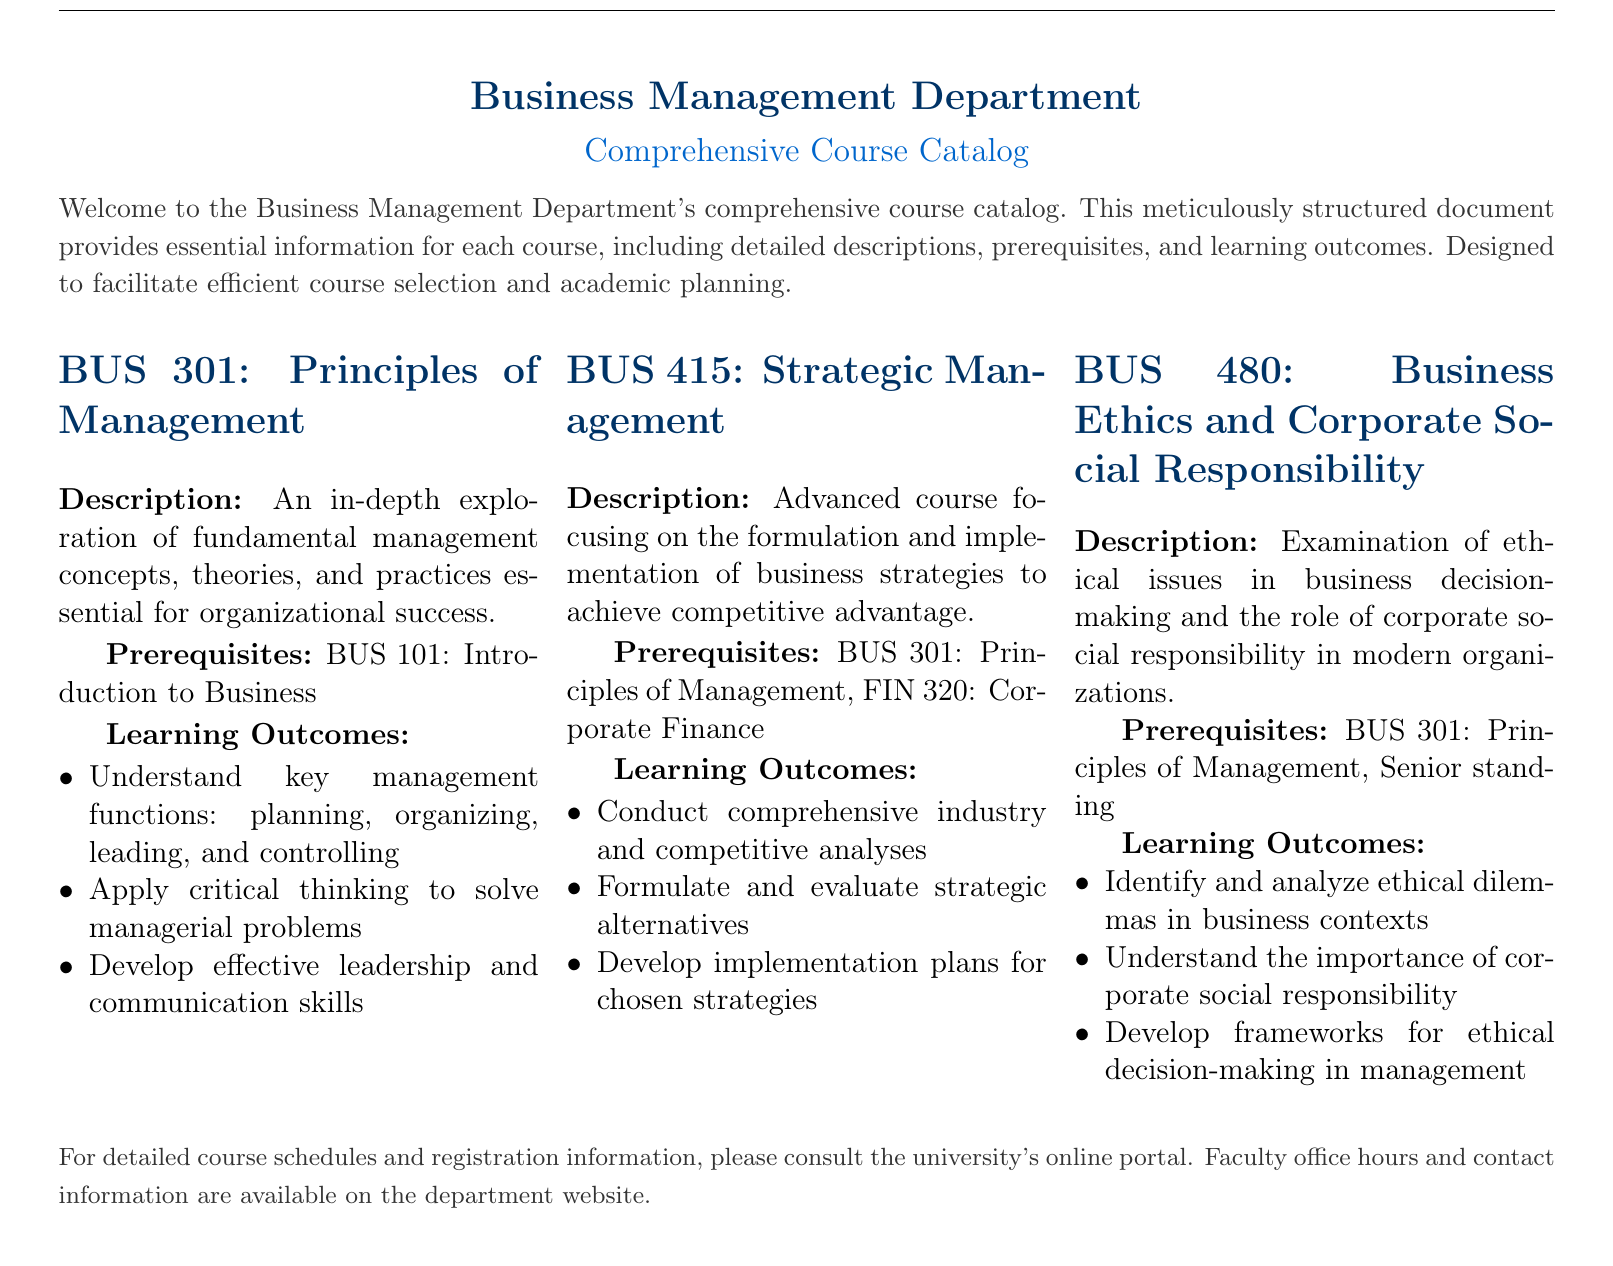What is the first course listed in the catalog? The first course listed in the catalog is BUS 301, which focuses on the Principles of Management.
Answer: BUS 301 What is a prerequisite for BUS 415? The prerequisite for BUS 415 is BUS 301: Principles of Management, as stated in the course description.
Answer: BUS 301: Principles of Management What is the learning outcome for BUS 480 related to ethical decision-making? The learning outcome for BUS 480 states the importance of developing frameworks for ethical decision-making in management.
Answer: Develop frameworks for ethical decision-making in management How many courses are described in the catalog? There are three courses described in the catalog, namely BUS 301, BUS 415, and BUS 480.
Answer: Three What is the focus of the BUS 415 course? The focus of BUS 415 is on the formulation and implementation of business strategies to achieve competitive advantage.
Answer: Formulation and implementation of business strategies What is the senior standing requirement? The requirement of senior standing is mentioned as a prerequisite for enrolling in BUS 480.
Answer: Senior standing What is a key management function taught in BUS 301? A key management function taught in BUS 301 is planning, organizing, leading, and controlling.
Answer: Planning, organizing, leading, and controlling What online resource is mentioned for course schedules? The online portal is mentioned as the resource for detailed course schedules and registration information.
Answer: University’s online portal 